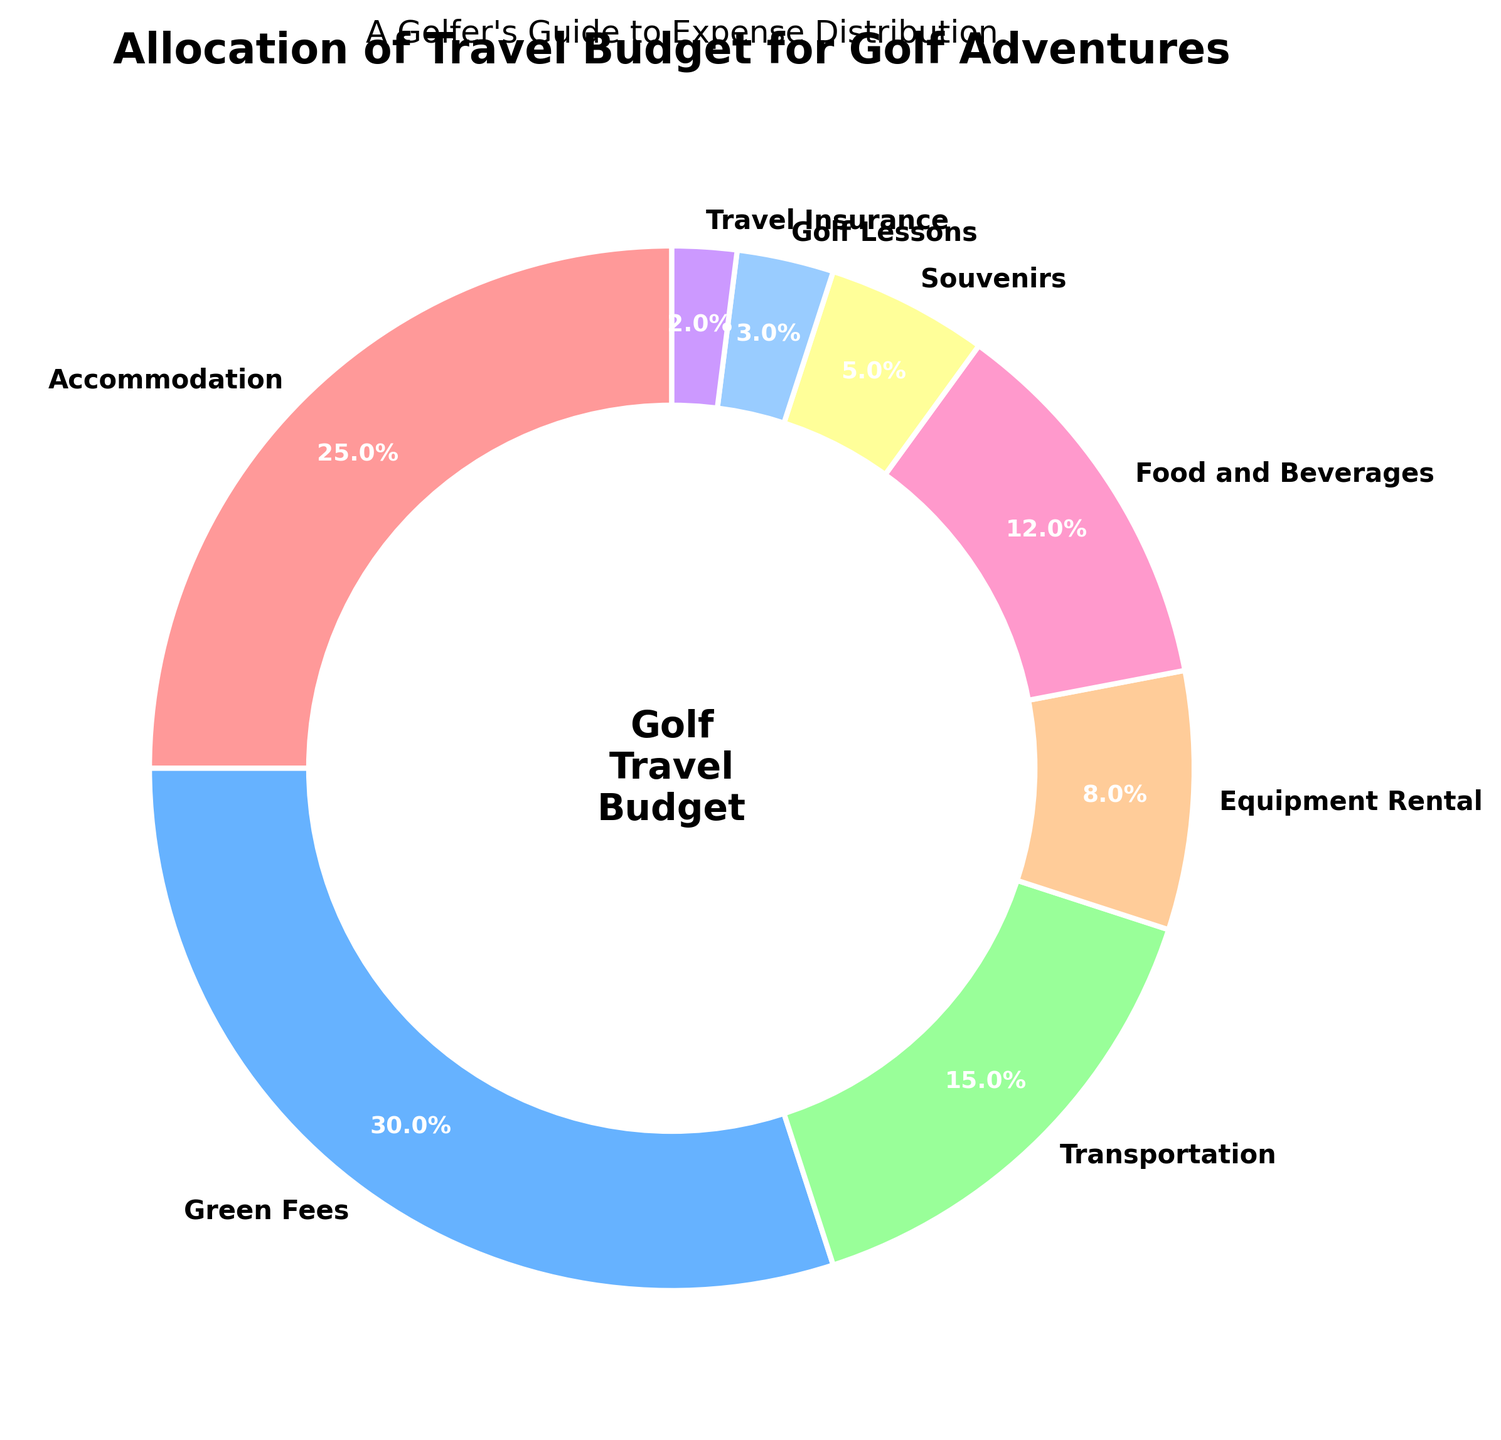What percentage of the travel budget is allocated to Accommodation and Food and Beverages combined? To find the combined percentage of the budget allocated to Accommodation and Food and Beverages, add the individual percentages: 25% for Accommodation and 12% for Food and Beverages. Therefore, the combined percentage is 25% + 12% = 37%.
Answer: 37% Which category takes up a larger percentage of the budget, Green Fees or Transportation? Compare the percentages of the budget allocated to Green Fees and Transportation. Green Fees have 30%, and Transportation has 15%. Therefore, Green Fees take up a larger percentage.
Answer: Green Fees How much more is spent on Green Fees than on Equipment Rental? Subtract the percentage of the budget for Equipment Rental (8%) from that of Green Fees (30%): 30% - 8% = 22%.
Answer: 22% What is the least allocated budget category, and what percentage of the budget does it receive? Identify the category with the smallest percentage allocation. Travel Insurance is the category with the smallest allocation, at 2%.
Answer: Travel Insurance, 2% Which categories have less than 10% of the budget allocated to them? Review the percentages and identify any categories under 10%. The categories with less than 10% are Equipment Rental (8%), Souvenirs (5%), Golf Lessons (3%), and Travel Insurance (2%).
Answer: Equipment Rental, Souvenirs, Golf Lessons, Travel Insurance By how much does the budget for Food and Beverages exceed the budget for Souvenirs? Subtract the budget percentage for Souvenirs (5%) from that for Food and Beverages (12%): 12% - 5% = 7%.
Answer: 7% What percentage of the budget is dedicated to non-golf-related expenses (Accommodation, Transportation, and Food and Beverages)? Add the percentages of the non-golf-related categories: Accommodation (25%), Transportation (15%), and Food and Beverages (12%). Thus, the non-golf-related expenses sum to 25% + 15% + 12% = 52%.
Answer: 52% Is the percentage allocated to Accommodation greater than, less than, or equal to the sum of the budgets for Souvenirs and Golf Lessons? Compare the Accommodation budget (25%) to the sum of Souvenirs and Golf Lessons (5% + 3% = 8%). The Accommodation budget (25%) is greater than the sum of Souvenirs and Golf Lessons (8%).
Answer: Greater than Which category is assigned more budget, Equipment Rental or Golf Lessons? Compare the percentages for Equipment Rental and Golf Lessons: Equipment Rental has 8%, and Golf Lessons has 3%. Therefore, Equipment Rental is assigned more budget.
Answer: Equipment Rental What percentage of the budget is allocated to the top three categories? Identify and sum the percentages of the top three categories: Green Fees (30%), Accommodation (25%), and Transportation (15%). The total percentage is 30% + 25% + 15% = 70%.
Answer: 70% 